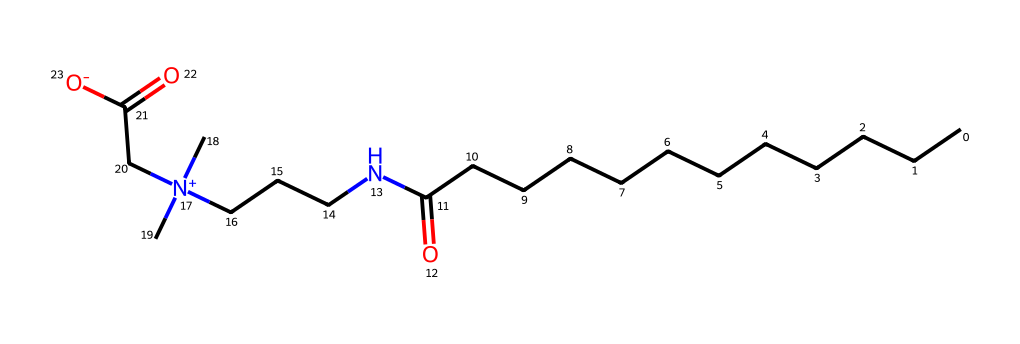What is the molecular formula of cocamidopropyl betaine based on the SMILES representation? To determine the molecular formula, we analyze the SMILES representation, counting the atoms of each element present: there are 14 carbon (C) atoms, 28 hydrogen (H) atoms, 1 nitrogen (N) atom, and 2 oxygen (O) atoms, resulting in a formula of C14H29N2O2.
Answer: C14H29N2O2 How many carbon atoms are in cocamidopropyl betaine? By analyzing the SMILES representation, we count the total number of C characters in the string, which indicates the number of carbon atoms. In this case, there are 14 C's.
Answer: 14 What type of chemical is cocamidopropyl betaine? Cocamidopropyl betaine is a zwitterionic surfactant. This can be determined by its structure, which includes both a positive and a negative charge, characteristic of zwitterionic compounds.
Answer: zwitterionic surfactant What functional groups are present in cocamidopropyl betaine? Analyzing the structure, we identify the carboxylic acid (-COOH) and amine (-NH) functional groups. These groups contribute to its surfactant properties.
Answer: carboxylic acid, amine What is the charge of the nitrogen atom in cocamidopropyl betaine? The nitrogen atom in the SMILES representation is indicated to carry a positive charge due to the notation [N+]. This reveals its ionic character in the molecular structure.
Answer: positive Why does cocamidopropyl betaine act as a foam booster in shampoos? Cocamidopropyl betaine has hydrophilic and hydrophobic regions due to its zwitterionic nature, which allows it to reduce surface tension and stabilize foam in solutions, particularly in aqueous environments like shampoos.
Answer: stabilizes foam How does the presence of the carboxylic acid group influence the properties of cocamidopropyl betaine? The carboxylic acid group contributes to solubility in water and enhances foaming properties due to its polar nature, allowing it to interact favorably with water molecules and surfactant structures.
Answer: enhances solubility and foaming 